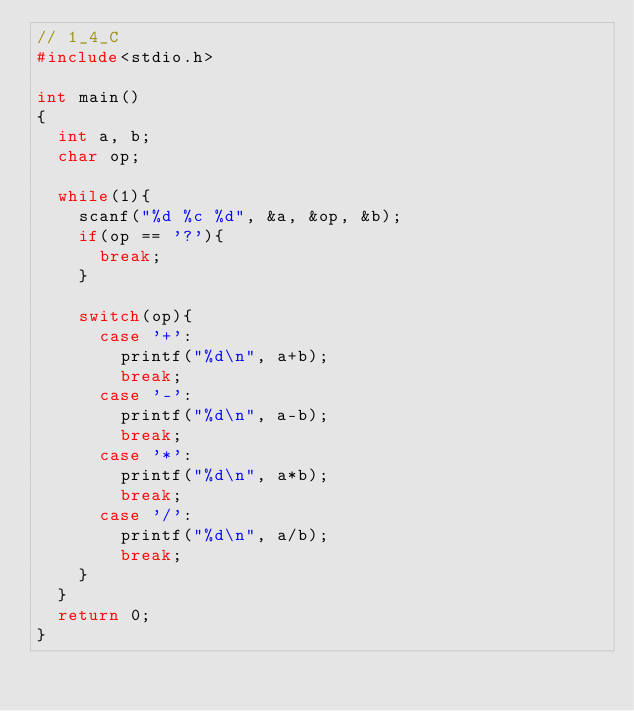Convert code to text. <code><loc_0><loc_0><loc_500><loc_500><_C_>// 1_4_C
#include<stdio.h>

int main()
{
	int a, b;
	char op;

	while(1){
		scanf("%d %c %d", &a, &op, &b);
		if(op == '?'){
			break;
		}

		switch(op){
			case '+':
				printf("%d\n", a+b);
				break;
			case '-':
				printf("%d\n", a-b);
				break;
			case '*':
				printf("%d\n", a*b);
				break;
			case '/':
				printf("%d\n", a/b);
				break;
		}
	}
	return 0;
}</code> 